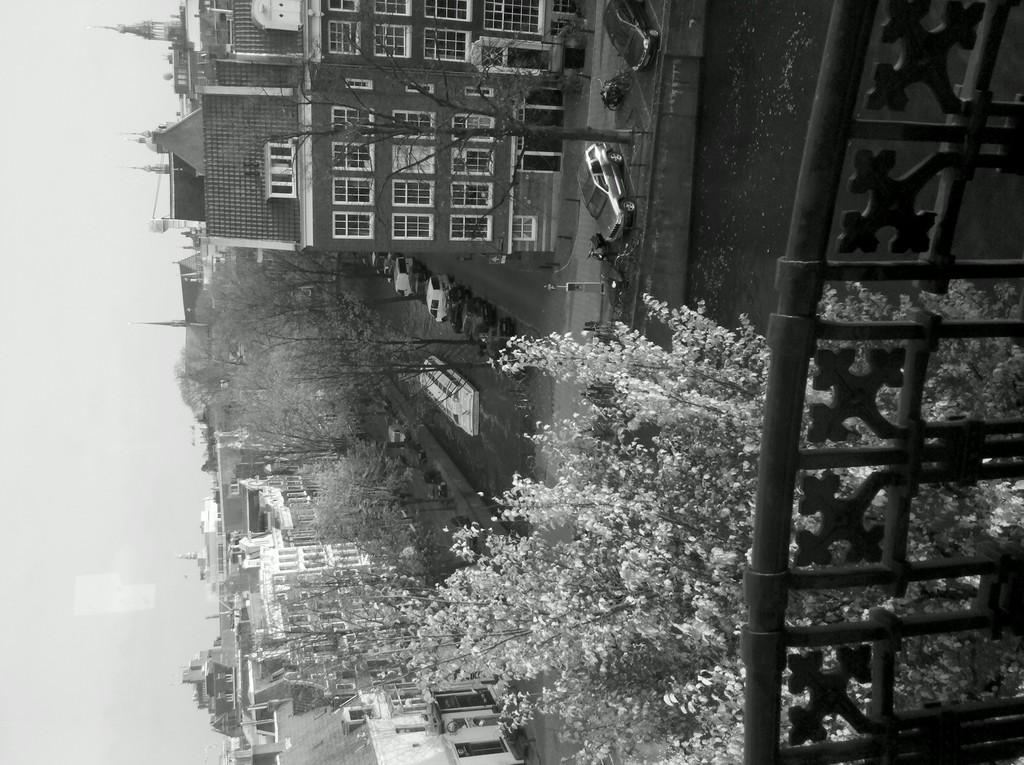Where was the image taken from? The image is taken from a balcony. What can be seen in the distance in the image? There are buildings visible in the image. What type of vegetation is present in the image? There are trees in the image. What type of transportation can be seen in the image? There are cars in the image. What type of air can be seen in the image? There is no air visible in the image, as it is a two-dimensional representation of a scene. 